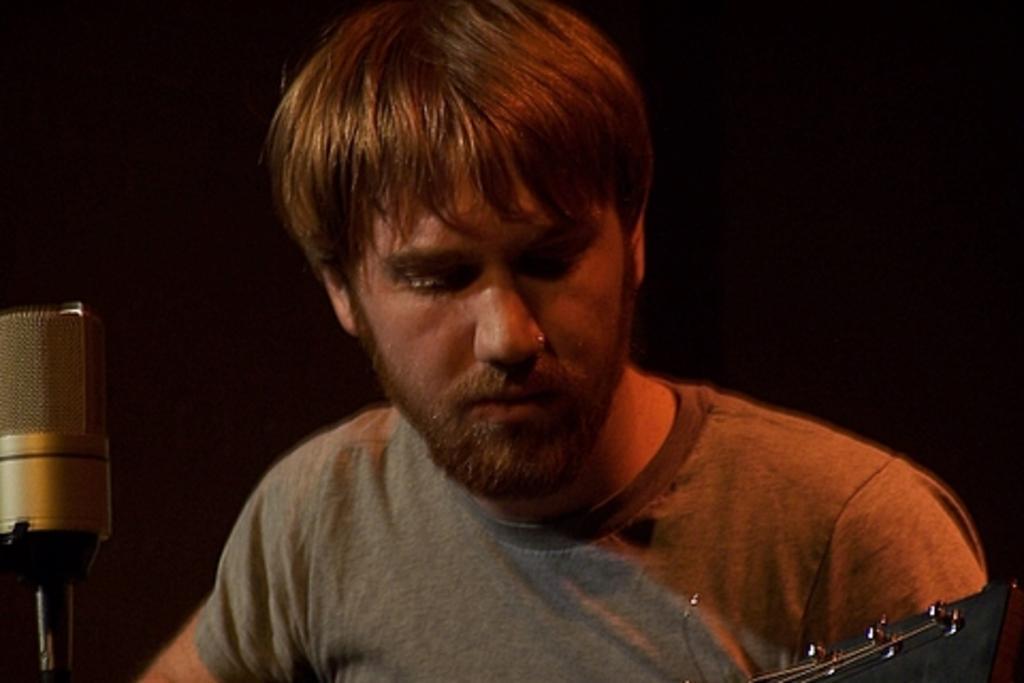Can you describe this image briefly? In this image I can see a man holding some musical instrument. This is a mike with the mike stand. And the background is dark. 